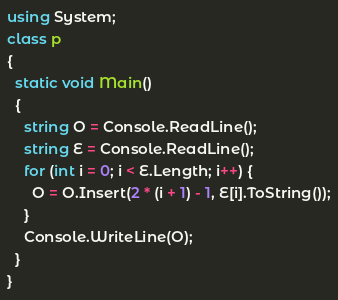<code> <loc_0><loc_0><loc_500><loc_500><_C#_>using System;
class p
{
  static void Main()
  {
    string O = Console.ReadLine();
    string E = Console.ReadLine();
    for (int i = 0; i < E.Length; i++) {
      O = O.Insert(2 * (i + 1) - 1, E[i].ToString());
    }
    Console.WriteLine(O);
  }
}</code> 